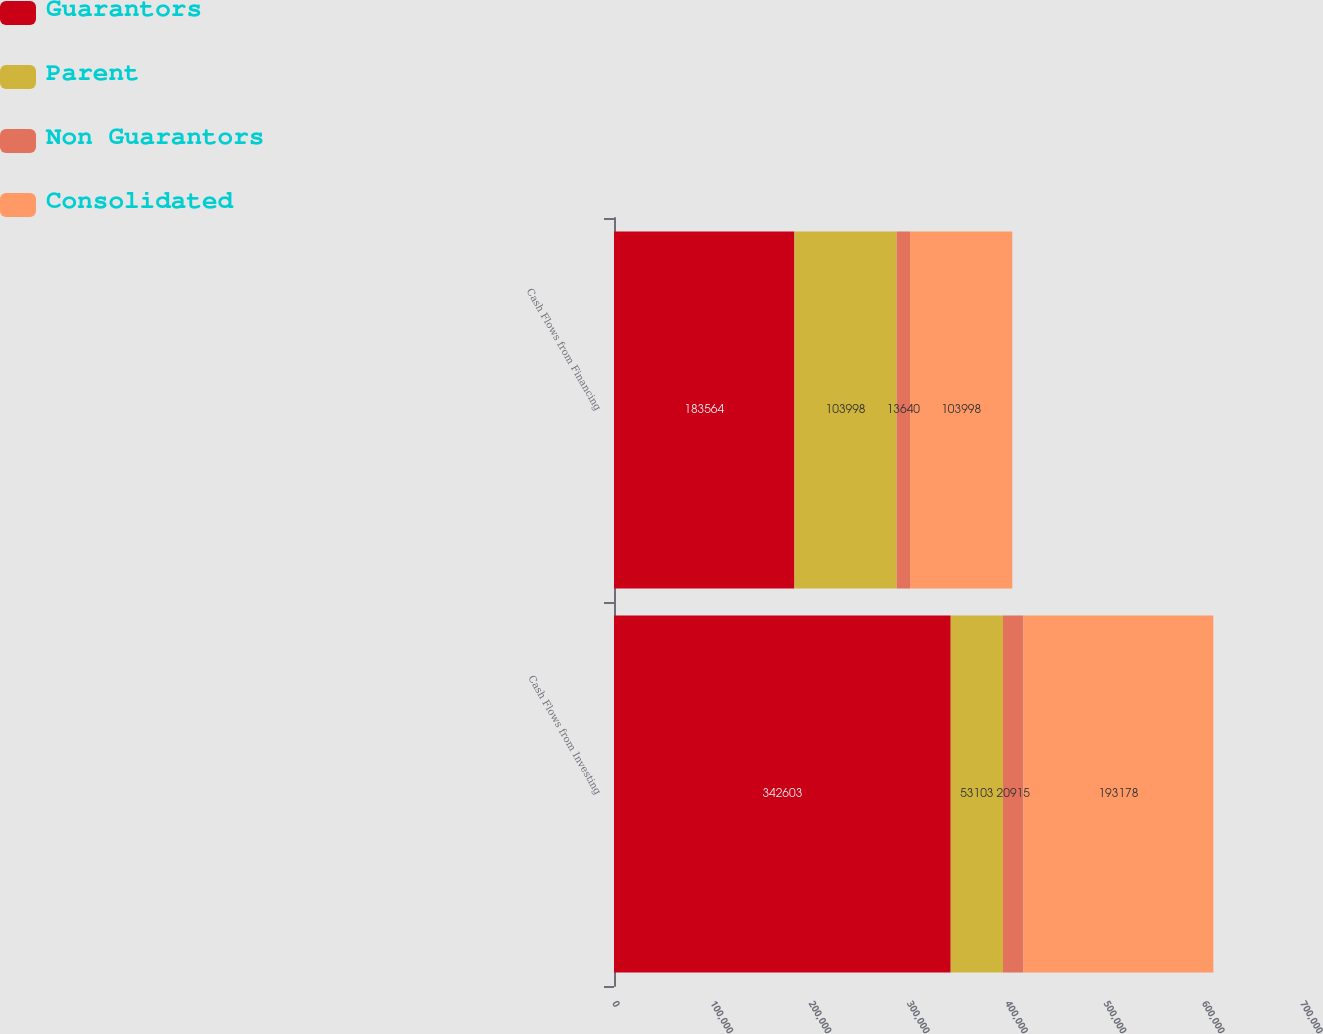<chart> <loc_0><loc_0><loc_500><loc_500><stacked_bar_chart><ecel><fcel>Cash Flows from Investing<fcel>Cash Flows from Financing<nl><fcel>Guarantors<fcel>342603<fcel>183564<nl><fcel>Parent<fcel>53103<fcel>103998<nl><fcel>Non Guarantors<fcel>20915<fcel>13640<nl><fcel>Consolidated<fcel>193178<fcel>103998<nl></chart> 